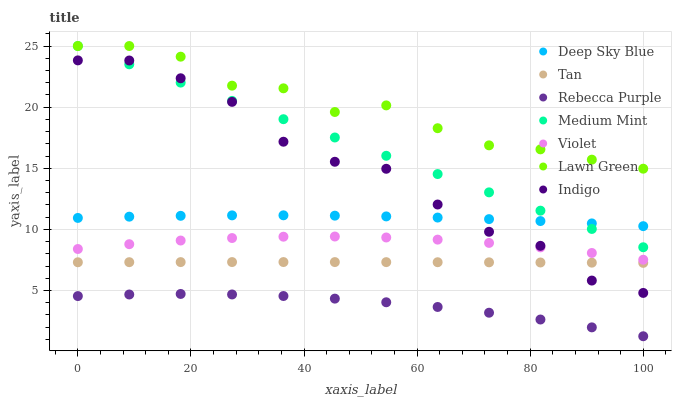Does Rebecca Purple have the minimum area under the curve?
Answer yes or no. Yes. Does Lawn Green have the maximum area under the curve?
Answer yes or no. Yes. Does Indigo have the minimum area under the curve?
Answer yes or no. No. Does Indigo have the maximum area under the curve?
Answer yes or no. No. Is Medium Mint the smoothest?
Answer yes or no. Yes. Is Indigo the roughest?
Answer yes or no. Yes. Is Lawn Green the smoothest?
Answer yes or no. No. Is Lawn Green the roughest?
Answer yes or no. No. Does Rebecca Purple have the lowest value?
Answer yes or no. Yes. Does Indigo have the lowest value?
Answer yes or no. No. Does Lawn Green have the highest value?
Answer yes or no. Yes. Does Indigo have the highest value?
Answer yes or no. No. Is Indigo less than Lawn Green?
Answer yes or no. Yes. Is Deep Sky Blue greater than Tan?
Answer yes or no. Yes. Does Tan intersect Indigo?
Answer yes or no. Yes. Is Tan less than Indigo?
Answer yes or no. No. Is Tan greater than Indigo?
Answer yes or no. No. Does Indigo intersect Lawn Green?
Answer yes or no. No. 